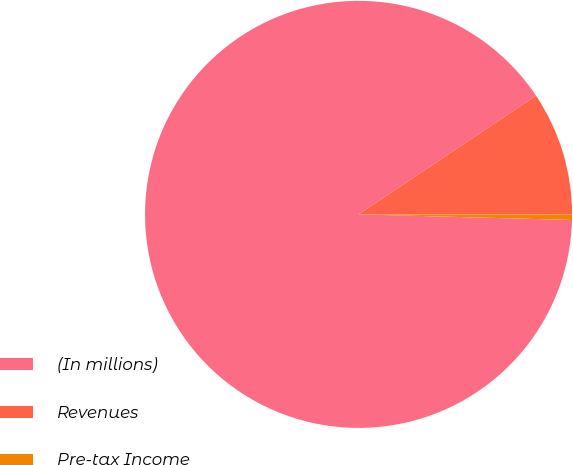<chart> <loc_0><loc_0><loc_500><loc_500><pie_chart><fcel>(In millions)<fcel>Revenues<fcel>Pre-tax Income<nl><fcel>90.2%<fcel>9.39%<fcel>0.41%<nl></chart> 